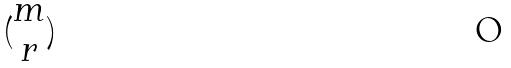<formula> <loc_0><loc_0><loc_500><loc_500>( \begin{matrix} m \\ r \end{matrix} )</formula> 